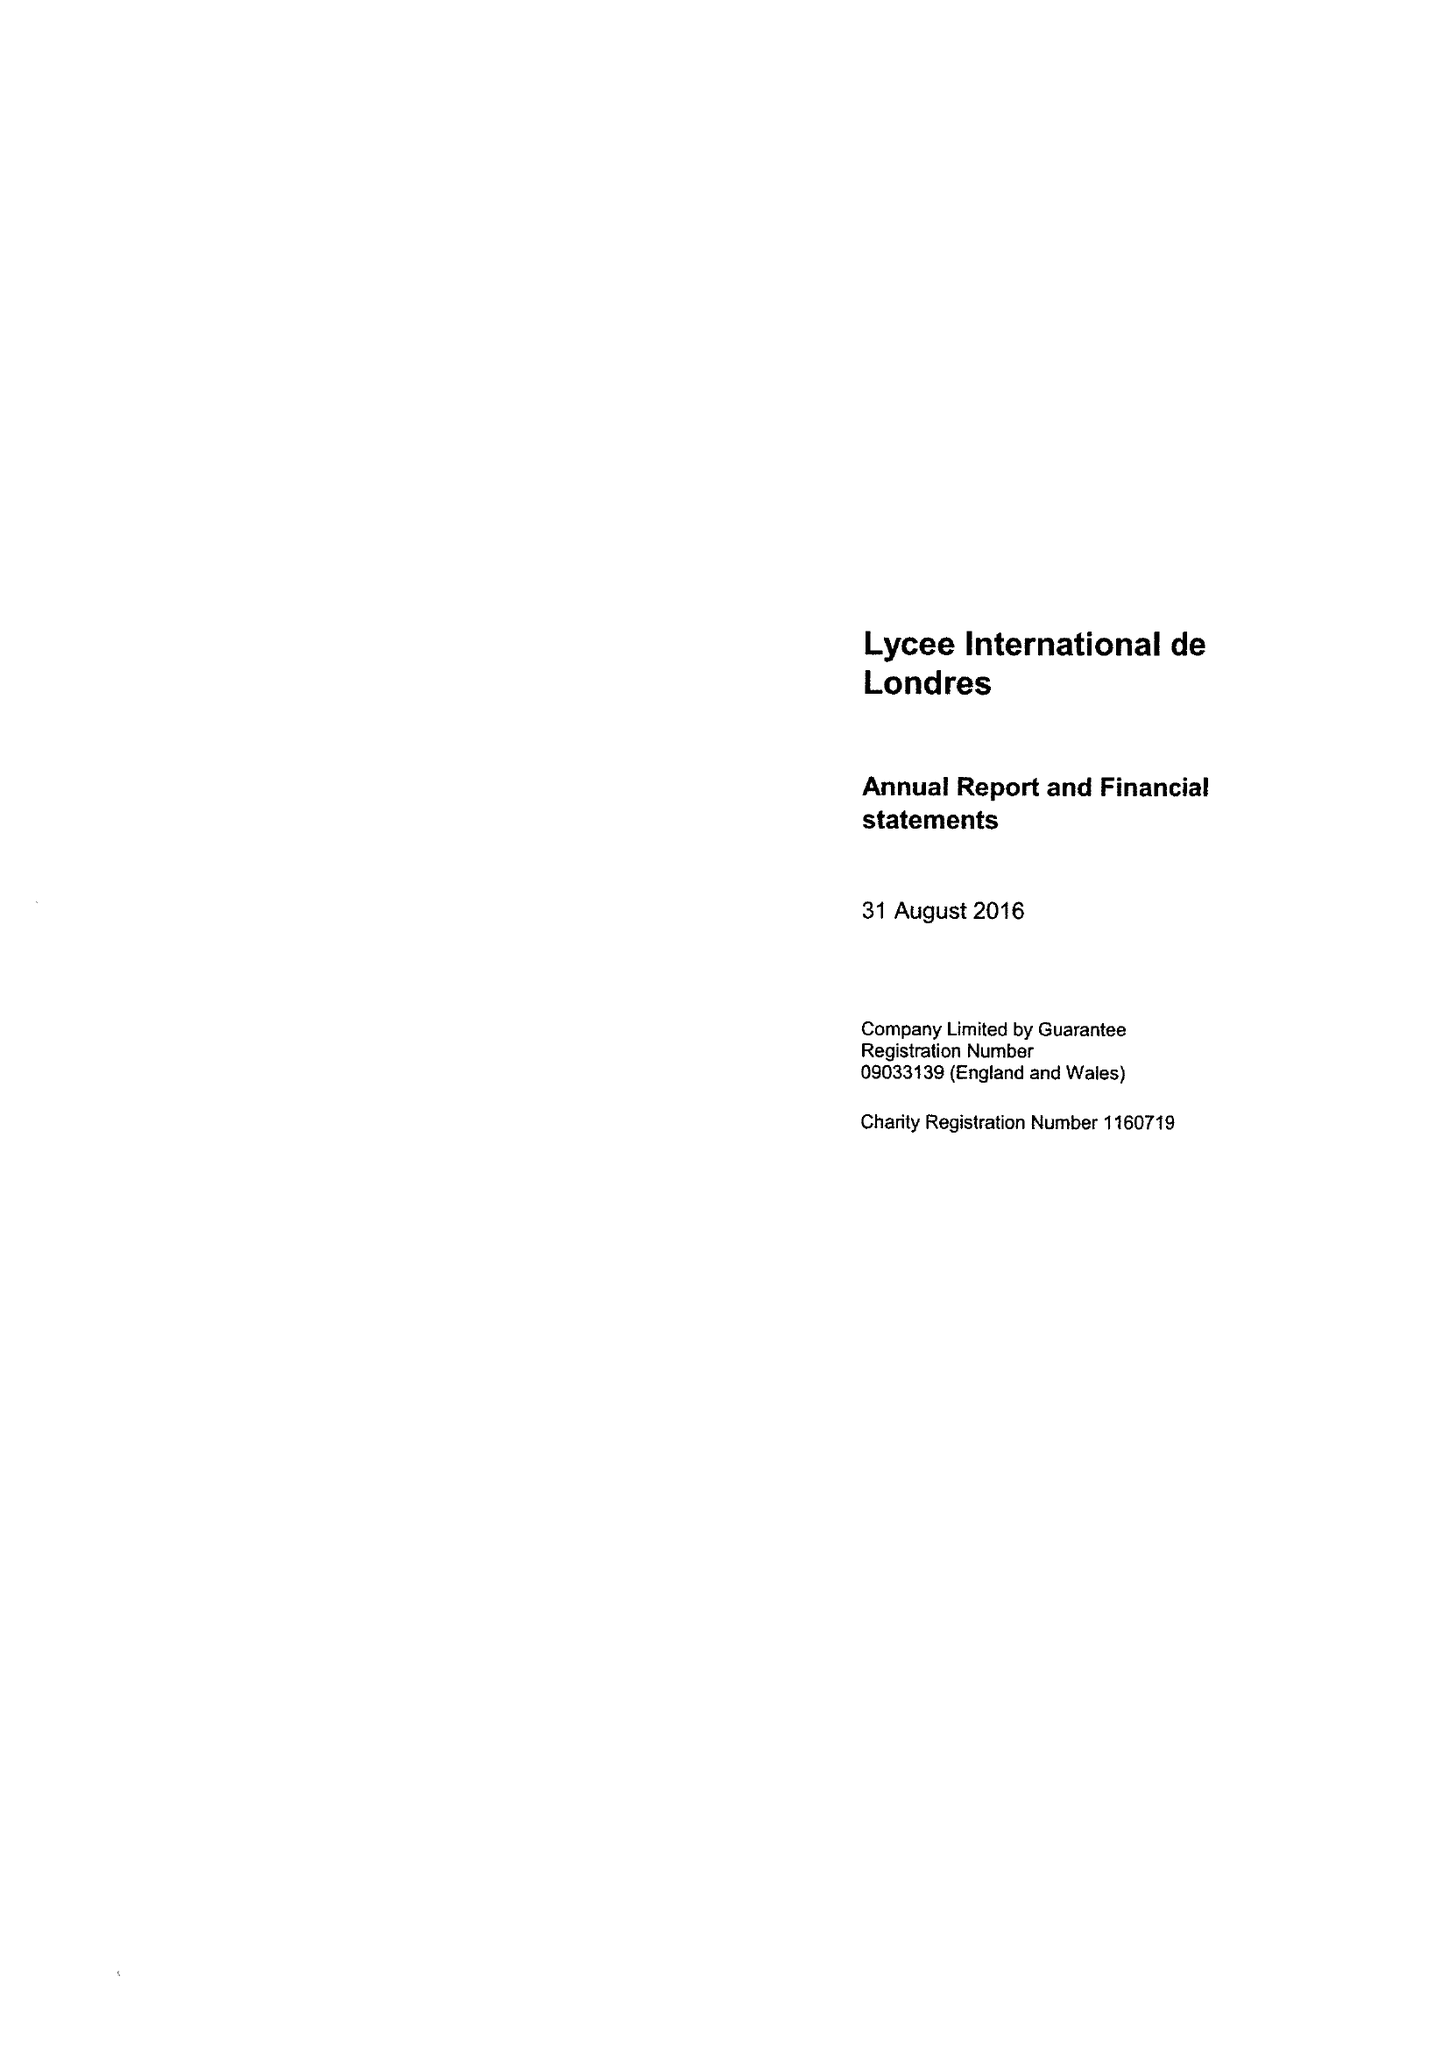What is the value for the spending_annually_in_british_pounds?
Answer the question using a single word or phrase. 5620068.00 